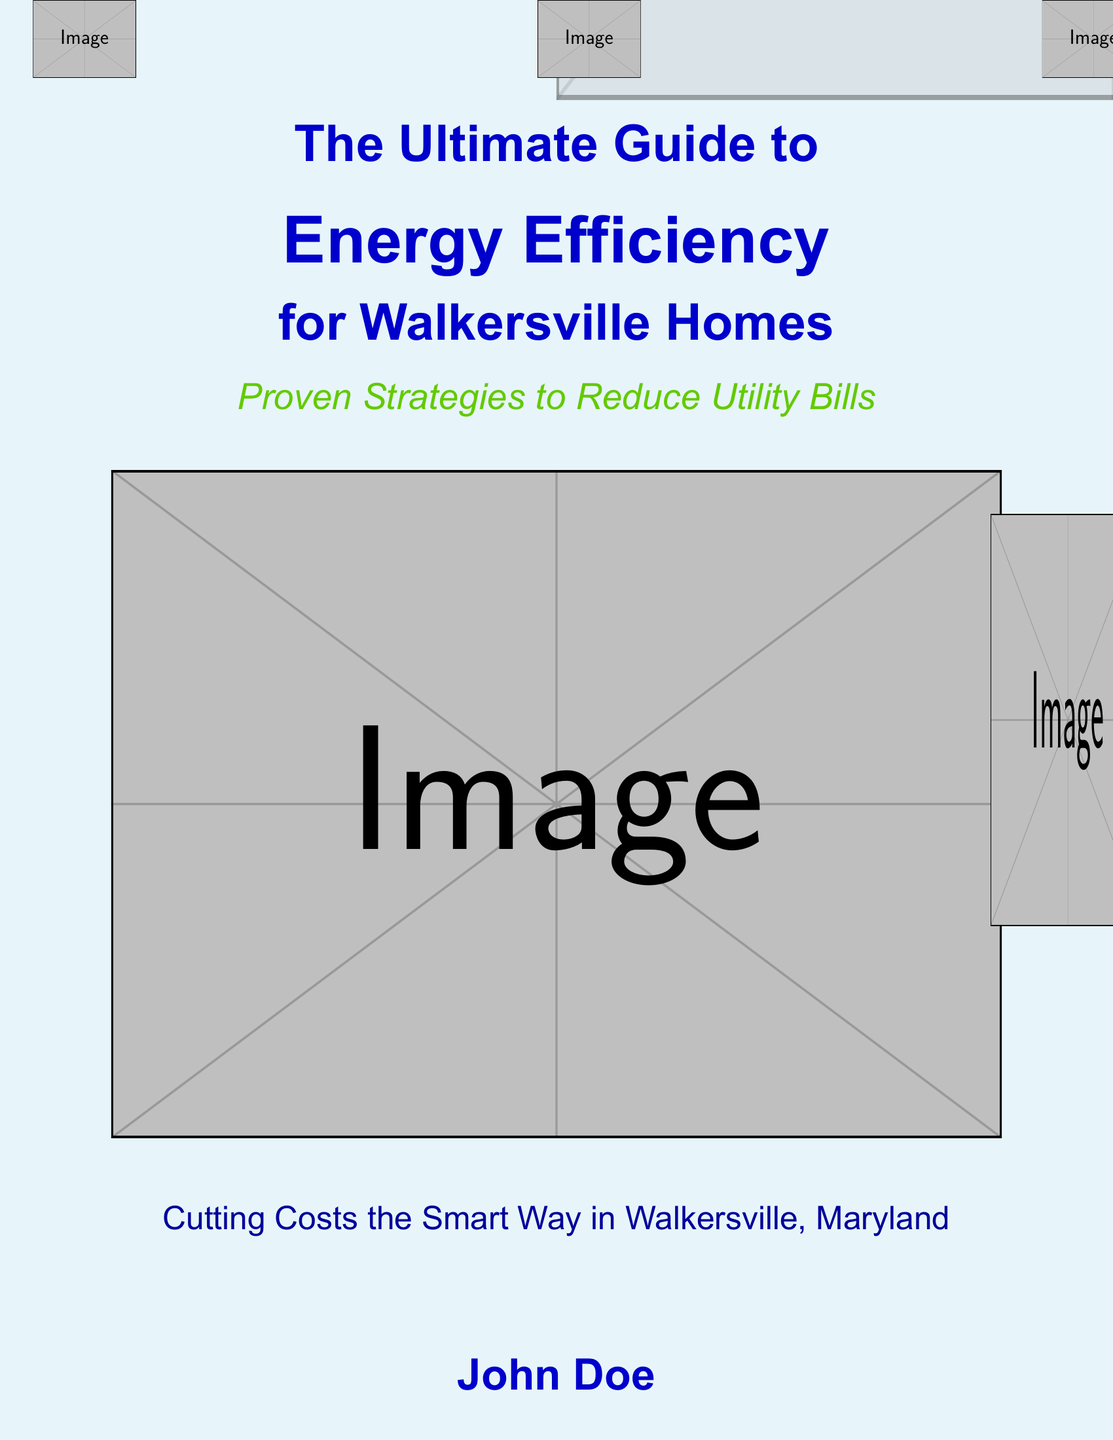What is the title of the book? The title of the book is prominently displayed in a large font on the cover.
Answer: The Ultimate Guide to Energy Efficiency for Walkersville Homes Who is the author of the book? The author's name is listed at the bottom of the cover in a distinct font.
Answer: John Doe What is the main focus of the book? The focus of the book, as indicated in the subtitle, is on reducing utility bills.
Answer: Proven Strategies to Reduce Utility Bills What color is the main background of the cover? The cover features a light blue background, which is specified by the document.
Answer: Skyblue What concept does the image on the cover convey? The imagery includes energy-saving icons that illustrate the theme of energy efficiency.
Answer: Energy efficiency Which town is specifically mentioned in the book title? The town specified in the title indicates the targeted audience for the book.
Answer: Walkersville How is the book described in terms of cost-saving? The book's theme suggests a practical approach to managing expenses.
Answer: Cutting Costs the Smart Way in Walkersville, Maryland What shape is the chart visible in the cover art implying? The chart appears to convey a visual reduction of energy consumption.
Answer: Lower energy consumption 